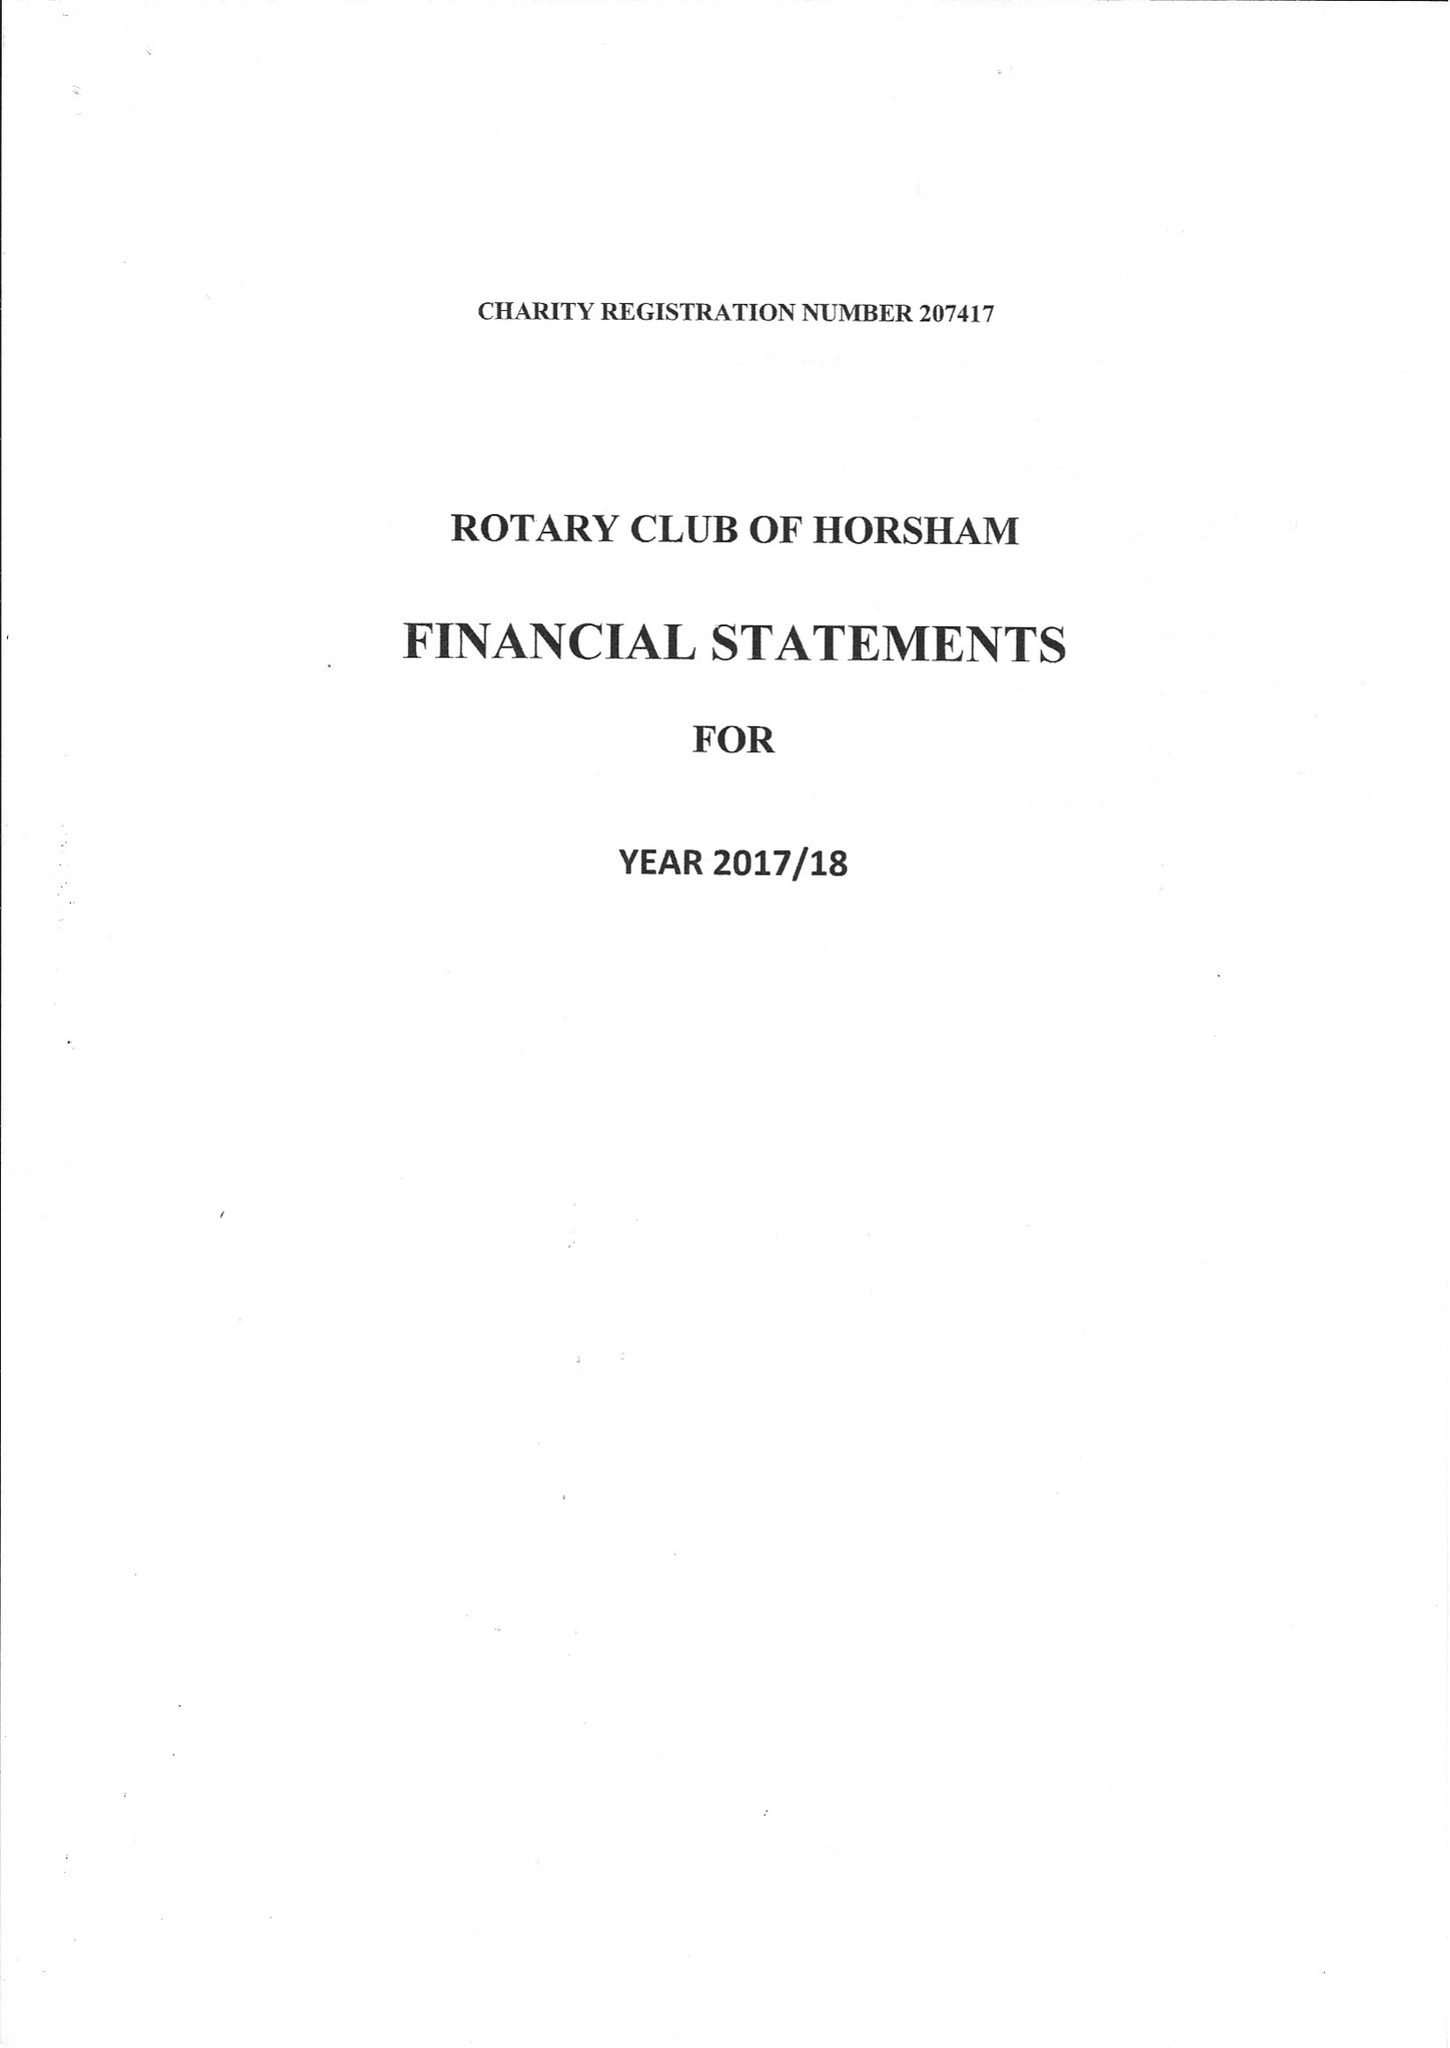What is the value for the address__post_town?
Answer the question using a single word or phrase. DORKING 